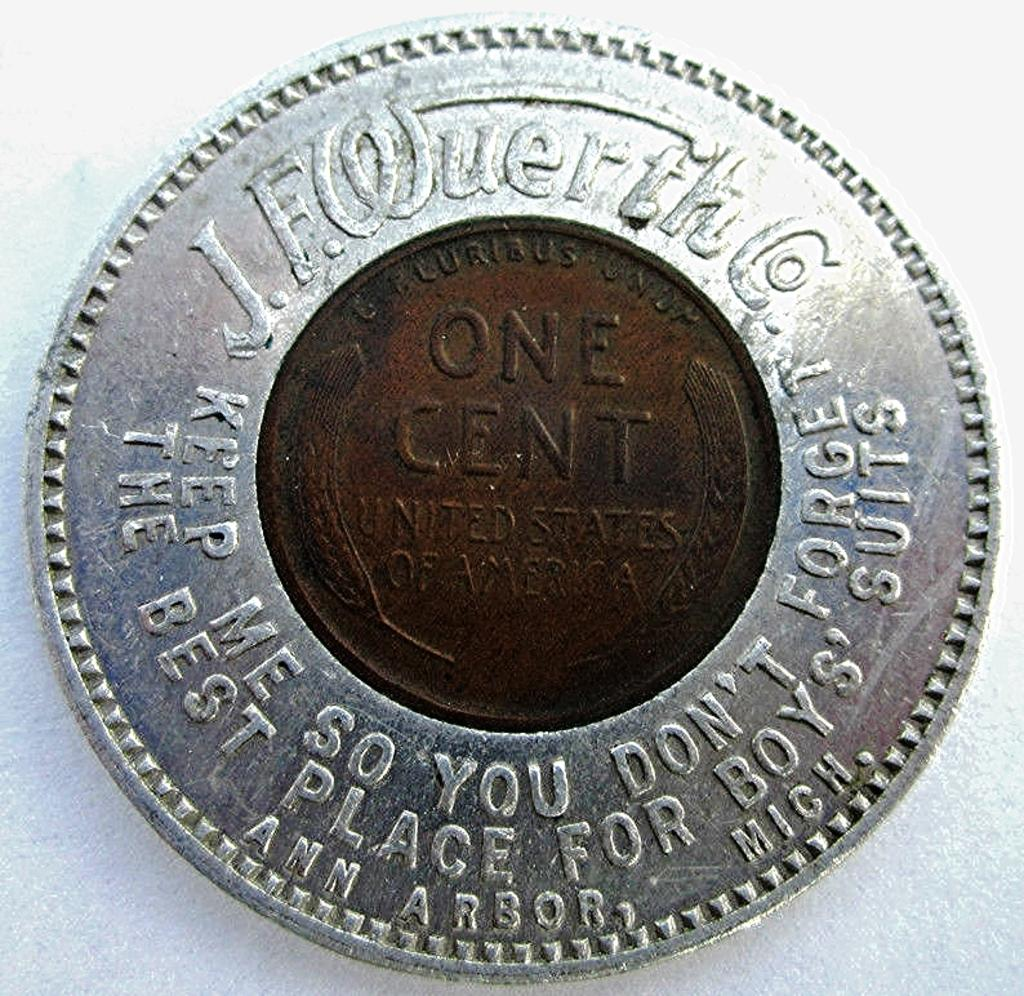<image>
Render a clear and concise summary of the photo. A one cent penny from the United States of America contained in a silver ring. 